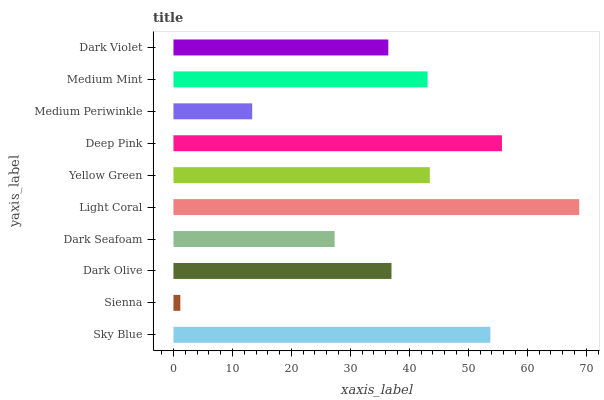Is Sienna the minimum?
Answer yes or no. Yes. Is Light Coral the maximum?
Answer yes or no. Yes. Is Dark Olive the minimum?
Answer yes or no. No. Is Dark Olive the maximum?
Answer yes or no. No. Is Dark Olive greater than Sienna?
Answer yes or no. Yes. Is Sienna less than Dark Olive?
Answer yes or no. Yes. Is Sienna greater than Dark Olive?
Answer yes or no. No. Is Dark Olive less than Sienna?
Answer yes or no. No. Is Medium Mint the high median?
Answer yes or no. Yes. Is Dark Olive the low median?
Answer yes or no. Yes. Is Dark Seafoam the high median?
Answer yes or no. No. Is Sienna the low median?
Answer yes or no. No. 